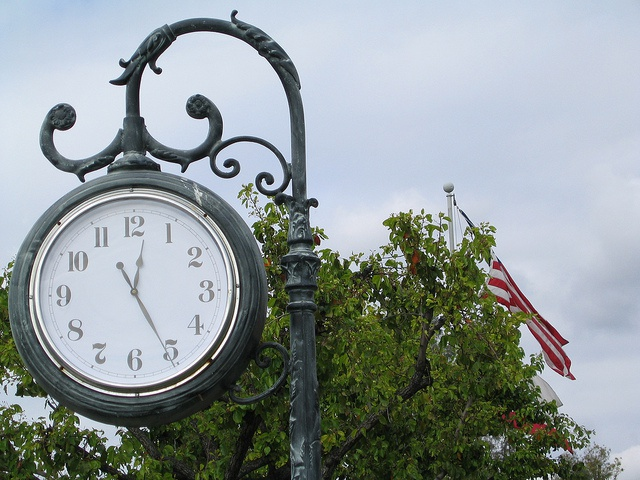Describe the objects in this image and their specific colors. I can see a clock in lightblue, lightgray, gray, black, and darkgray tones in this image. 